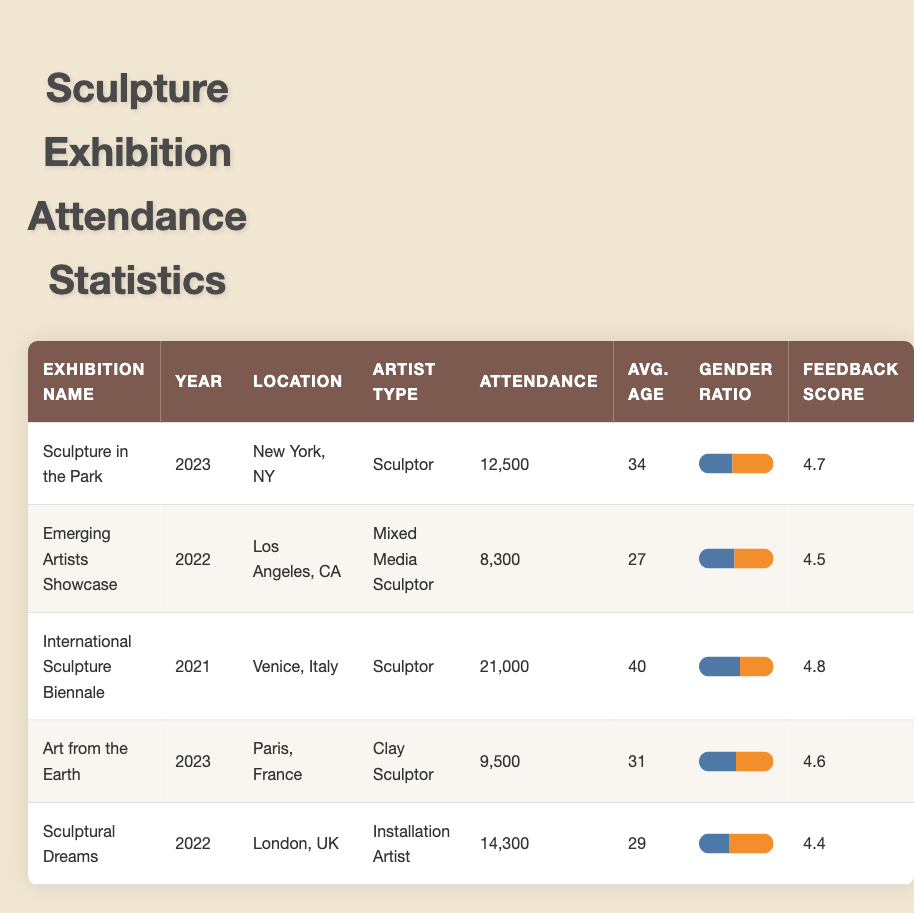What was the attendance for the International Sculpture Biennale in 2021? The record for the International Sculpture Biennale in 2021 is listed under the "Attendance" column in the corresponding row, which shows an attendance of 21,000.
Answer: 21,000 What is the average age of attendees for the exhibition "Sculpture in the Park"? To find this, we look at the row for "Sculpture in the Park" and find that the average age listed is 34.
Answer: 34 Was the feedback score higher for the Clay Sculptor exhibition or the Mixed Media Sculptor exhibition? The feedback score for "Art from the Earth" (Clay Sculptor) is 4.6, while for "Emerging Artists Showcase" (Mixed Media Sculptor) it is 4.5. Comparing these, 4.6 is higher than 4.5.
Answer: Yes How many total attendees were recorded across all exhibitions listed in the table? Total attendees can be calculated by adding the attendance figures from each row: 12,500 + 8,300 + 21,000 + 9,500 + 14,300 = 65,600.
Answer: 65,600 In which location did the exhibition with the highest attendance occur? The exhibition with the highest attendance is the "International Sculpture Biennale," which took place in Venice, Italy.
Answer: Venice, Italy What is the gender ratio of the Sculptural Dreams exhibition? In the row for "Sculptural Dreams," the gender ratio is displayed, indicating 40% male and 60% female.
Answer: 40% male, 60% female Which exhibition had the youngest average age of attendees and what was that age? From the table, the exhibition with the youngest average age is "Emerging Artists Showcase" with an average age of 27.
Answer: Emerging Artists Showcase; 27 Was the feedback score for the exhibition "Sculpture in the Park" above 4.5? The feedback score for "Sculpture in the Park" is 4.7, which is indeed above 4.5.
Answer: Yes What was the difference in attendance between the "Sculpture in the Park" and "Art from the Earth" exhibitions? To find the difference in attendance, we subtract the attendance for "Art from the Earth" (9,500) from "Sculpture in the Park" (12,500): 12,500 - 9,500 = 3,000.
Answer: 3,000 